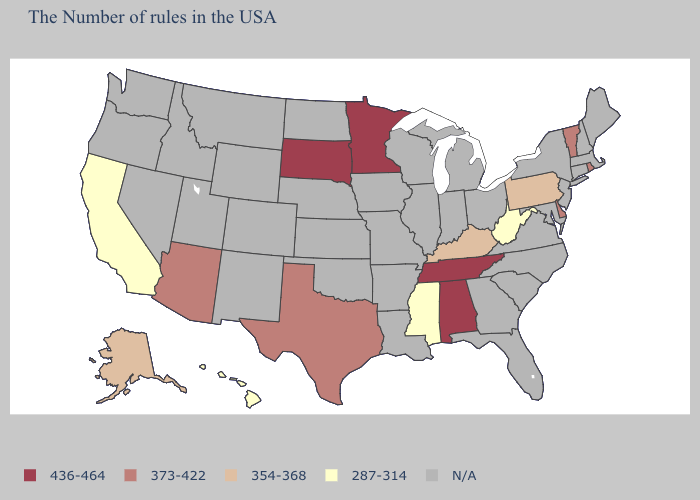What is the value of Indiana?
Quick response, please. N/A. What is the value of Rhode Island?
Keep it brief. 373-422. Among the states that border Arizona , which have the highest value?
Be succinct. California. Name the states that have a value in the range 354-368?
Quick response, please. Pennsylvania, Kentucky, Alaska. Which states have the lowest value in the South?
Answer briefly. West Virginia, Mississippi. Name the states that have a value in the range 373-422?
Give a very brief answer. Rhode Island, Vermont, Delaware, Texas, Arizona. Among the states that border Oklahoma , which have the lowest value?
Keep it brief. Texas. Among the states that border Maryland , which have the highest value?
Write a very short answer. Delaware. Is the legend a continuous bar?
Concise answer only. No. Name the states that have a value in the range 373-422?
Short answer required. Rhode Island, Vermont, Delaware, Texas, Arizona. Does South Dakota have the highest value in the USA?
Give a very brief answer. Yes. What is the value of California?
Be succinct. 287-314. 